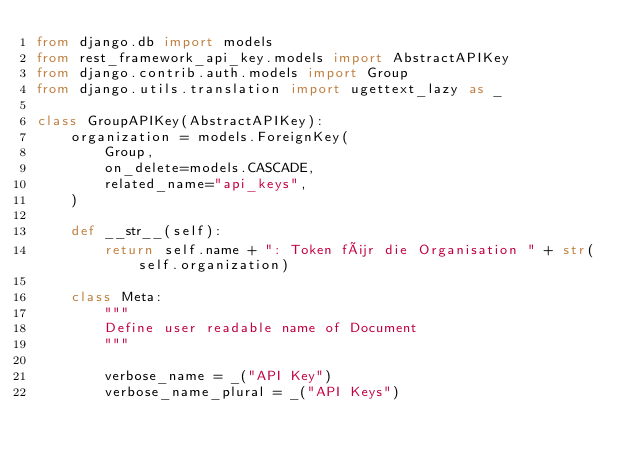Convert code to text. <code><loc_0><loc_0><loc_500><loc_500><_Python_>from django.db import models
from rest_framework_api_key.models import AbstractAPIKey
from django.contrib.auth.models import Group
from django.utils.translation import ugettext_lazy as _

class GroupAPIKey(AbstractAPIKey):
    organization = models.ForeignKey(
        Group,
        on_delete=models.CASCADE,
        related_name="api_keys",
    )

    def __str__(self):
        return self.name + ": Token für die Organisation " + str(self.organization)

    class Meta:
        """
        Define user readable name of Document
        """

        verbose_name = _("API Key")
        verbose_name_plural = _("API Keys")
</code> 